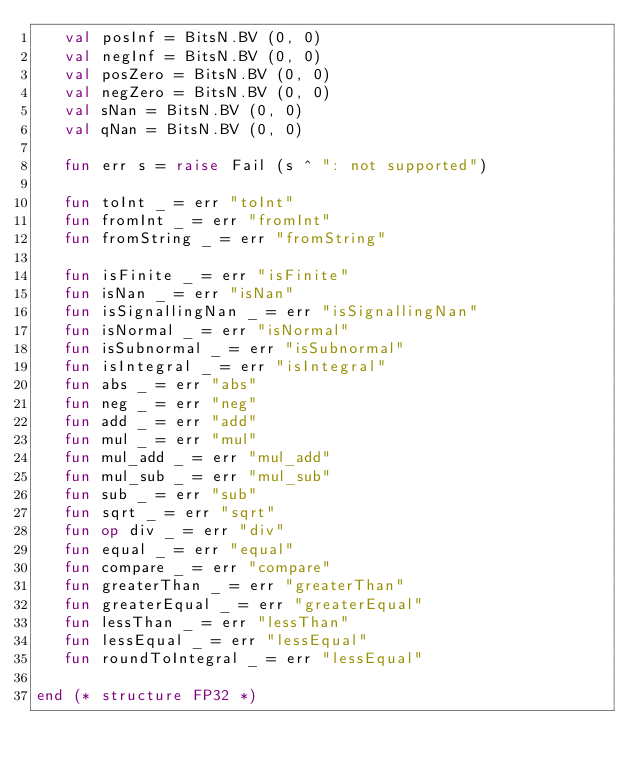Convert code to text. <code><loc_0><loc_0><loc_500><loc_500><_SML_>   val posInf = BitsN.BV (0, 0)
   val negInf = BitsN.BV (0, 0)
   val posZero = BitsN.BV (0, 0)
   val negZero = BitsN.BV (0, 0)
   val sNan = BitsN.BV (0, 0)
   val qNan = BitsN.BV (0, 0)

   fun err s = raise Fail (s ^ ": not supported")

   fun toInt _ = err "toInt"
   fun fromInt _ = err "fromInt"
   fun fromString _ = err "fromString"

   fun isFinite _ = err "isFinite"
   fun isNan _ = err "isNan"
   fun isSignallingNan _ = err "isSignallingNan"
   fun isNormal _ = err "isNormal"
   fun isSubnormal _ = err "isSubnormal"
   fun isIntegral _ = err "isIntegral"
   fun abs _ = err "abs"
   fun neg _ = err "neg"
   fun add _ = err "add"
   fun mul _ = err "mul"
   fun mul_add _ = err "mul_add"
   fun mul_sub _ = err "mul_sub"
   fun sub _ = err "sub"
   fun sqrt _ = err "sqrt"
   fun op div _ = err "div"
   fun equal _ = err "equal"
   fun compare _ = err "compare"
   fun greaterThan _ = err "greaterThan"
   fun greaterEqual _ = err "greaterEqual"
   fun lessThan _ = err "lessThan"
   fun lessEqual _ = err "lessEqual"
   fun roundToIntegral _ = err "lessEqual"

end (* structure FP32 *)
</code> 